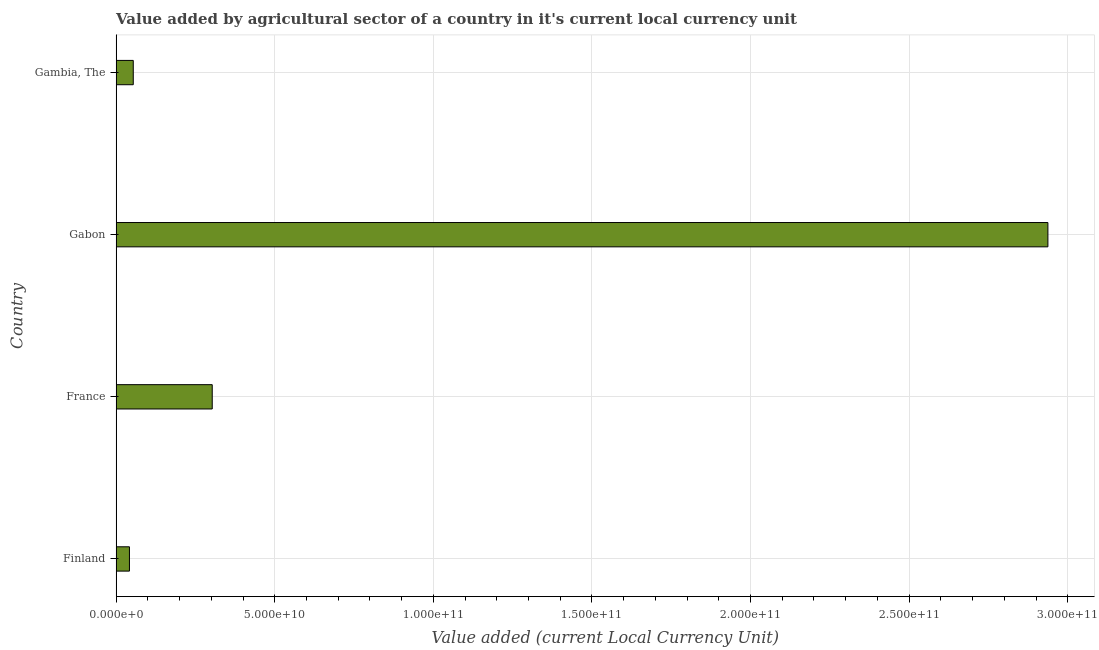What is the title of the graph?
Your response must be concise. Value added by agricultural sector of a country in it's current local currency unit. What is the label or title of the X-axis?
Offer a terse response. Value added (current Local Currency Unit). What is the label or title of the Y-axis?
Give a very brief answer. Country. What is the value added by agriculture sector in Finland?
Give a very brief answer. 4.20e+09. Across all countries, what is the maximum value added by agriculture sector?
Offer a very short reply. 2.94e+11. Across all countries, what is the minimum value added by agriculture sector?
Your answer should be compact. 4.20e+09. In which country was the value added by agriculture sector maximum?
Make the answer very short. Gabon. In which country was the value added by agriculture sector minimum?
Make the answer very short. Finland. What is the sum of the value added by agriculture sector?
Offer a very short reply. 3.34e+11. What is the difference between the value added by agriculture sector in Finland and Gabon?
Your answer should be compact. -2.90e+11. What is the average value added by agriculture sector per country?
Give a very brief answer. 8.34e+1. What is the median value added by agriculture sector?
Offer a terse response. 1.78e+1. In how many countries, is the value added by agriculture sector greater than 250000000000 LCU?
Offer a terse response. 1. What is the ratio of the value added by agriculture sector in France to that in Gabon?
Your response must be concise. 0.1. What is the difference between the highest and the second highest value added by agriculture sector?
Offer a very short reply. 2.63e+11. Is the sum of the value added by agriculture sector in Finland and Gambia, The greater than the maximum value added by agriculture sector across all countries?
Give a very brief answer. No. What is the difference between the highest and the lowest value added by agriculture sector?
Keep it short and to the point. 2.90e+11. Are all the bars in the graph horizontal?
Ensure brevity in your answer.  Yes. How many countries are there in the graph?
Keep it short and to the point. 4. What is the difference between two consecutive major ticks on the X-axis?
Make the answer very short. 5.00e+1. Are the values on the major ticks of X-axis written in scientific E-notation?
Offer a terse response. Yes. What is the Value added (current Local Currency Unit) of Finland?
Your response must be concise. 4.20e+09. What is the Value added (current Local Currency Unit) in France?
Your answer should be compact. 3.03e+1. What is the Value added (current Local Currency Unit) of Gabon?
Your response must be concise. 2.94e+11. What is the Value added (current Local Currency Unit) in Gambia, The?
Provide a succinct answer. 5.40e+09. What is the difference between the Value added (current Local Currency Unit) in Finland and France?
Provide a short and direct response. -2.61e+1. What is the difference between the Value added (current Local Currency Unit) in Finland and Gabon?
Your response must be concise. -2.90e+11. What is the difference between the Value added (current Local Currency Unit) in Finland and Gambia, The?
Ensure brevity in your answer.  -1.20e+09. What is the difference between the Value added (current Local Currency Unit) in France and Gabon?
Give a very brief answer. -2.63e+11. What is the difference between the Value added (current Local Currency Unit) in France and Gambia, The?
Your response must be concise. 2.49e+1. What is the difference between the Value added (current Local Currency Unit) in Gabon and Gambia, The?
Your response must be concise. 2.88e+11. What is the ratio of the Value added (current Local Currency Unit) in Finland to that in France?
Your response must be concise. 0.14. What is the ratio of the Value added (current Local Currency Unit) in Finland to that in Gabon?
Your answer should be very brief. 0.01. What is the ratio of the Value added (current Local Currency Unit) in Finland to that in Gambia, The?
Offer a very short reply. 0.78. What is the ratio of the Value added (current Local Currency Unit) in France to that in Gabon?
Provide a succinct answer. 0.1. What is the ratio of the Value added (current Local Currency Unit) in France to that in Gambia, The?
Make the answer very short. 5.61. What is the ratio of the Value added (current Local Currency Unit) in Gabon to that in Gambia, The?
Keep it short and to the point. 54.39. 